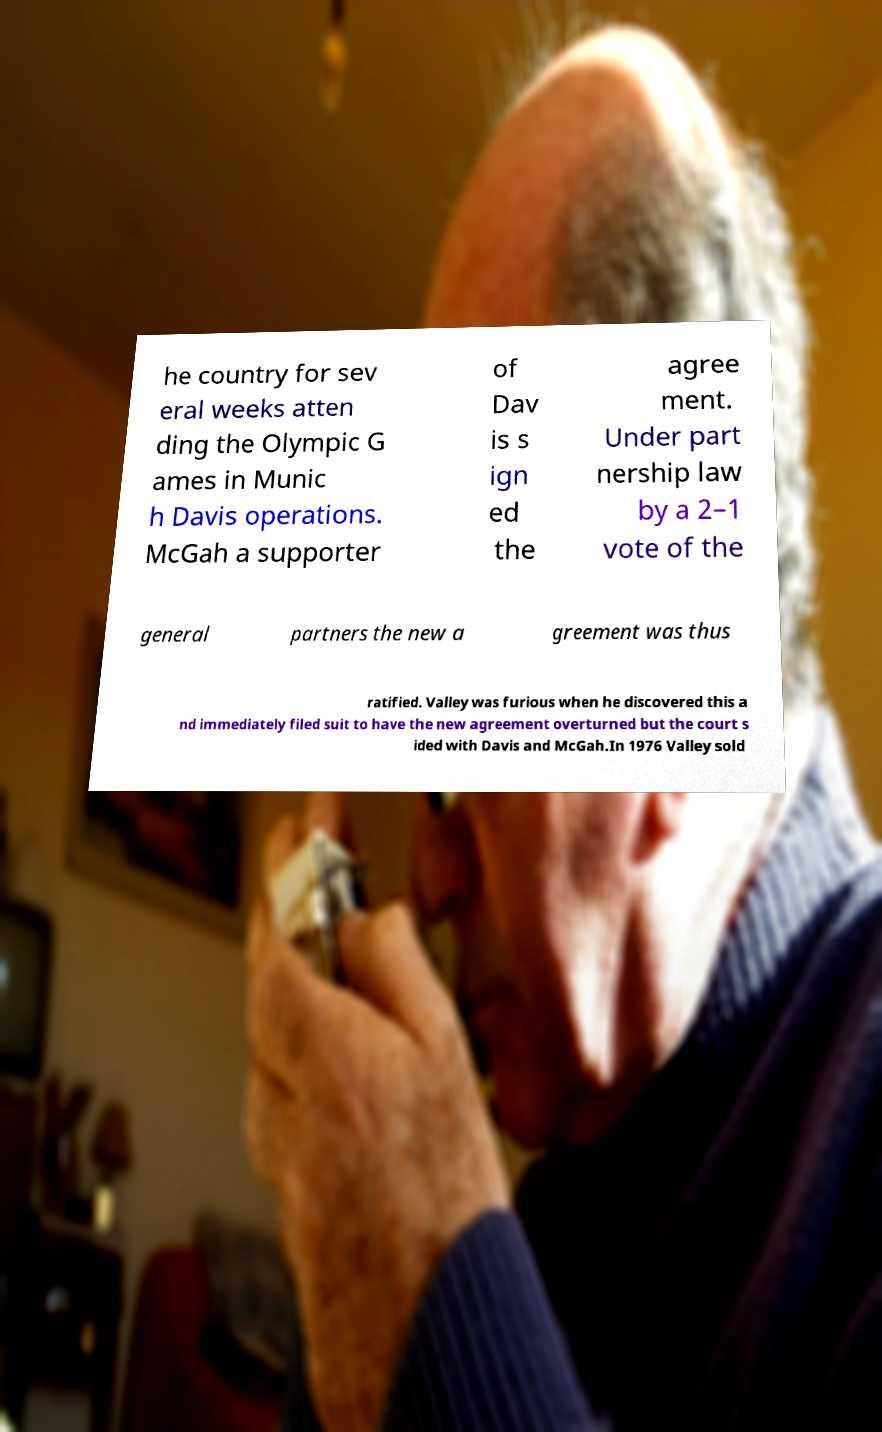Please identify and transcribe the text found in this image. he country for sev eral weeks atten ding the Olympic G ames in Munic h Davis operations. McGah a supporter of Dav is s ign ed the agree ment. Under part nership law by a 2–1 vote of the general partners the new a greement was thus ratified. Valley was furious when he discovered this a nd immediately filed suit to have the new agreement overturned but the court s ided with Davis and McGah.In 1976 Valley sold 